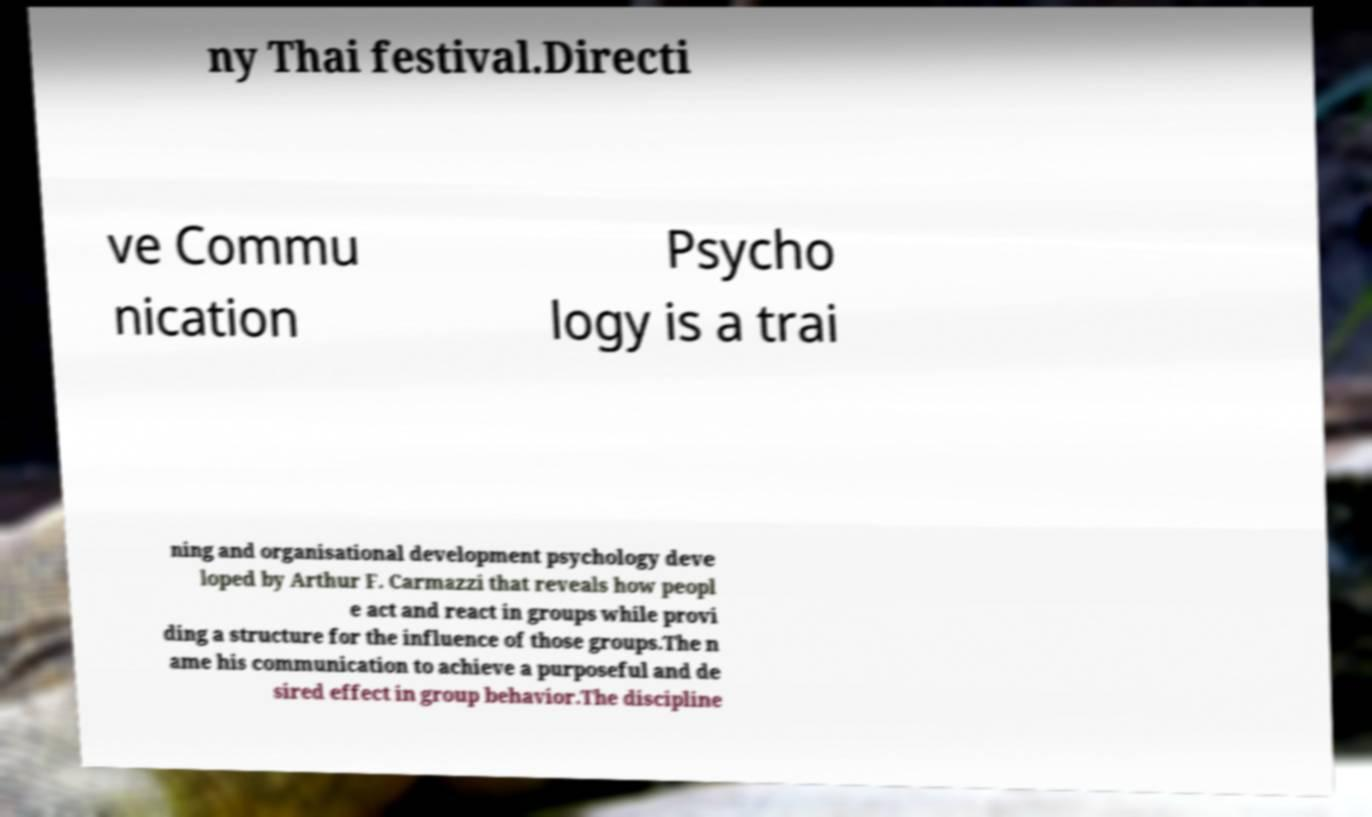Can you accurately transcribe the text from the provided image for me? ny Thai festival.Directi ve Commu nication Psycho logy is a trai ning and organisational development psychology deve loped by Arthur F. Carmazzi that reveals how peopl e act and react in groups while provi ding a structure for the influence of those groups.The n ame his communication to achieve a purposeful and de sired effect in group behavior.The discipline 